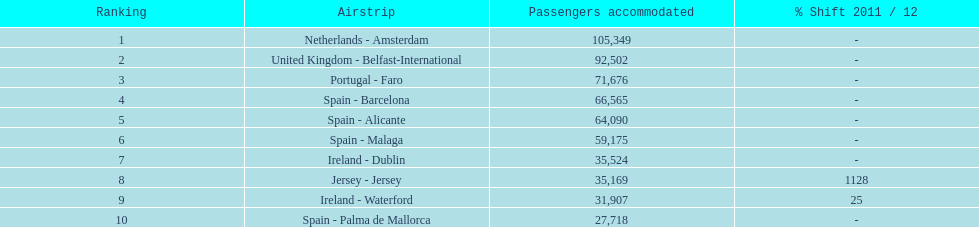Between the topped ranked airport, netherlands - amsterdam, & spain - palma de mallorca, what is the difference in the amount of passengers handled? 77,631. 